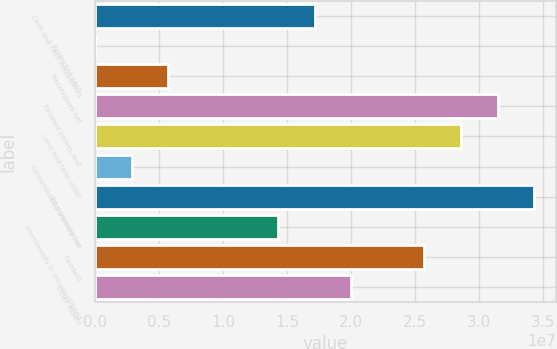Convert chart to OTSL. <chart><loc_0><loc_0><loc_500><loc_500><bar_chart><fcel>Cash and cash equivalents<fcel>Restricted cash<fcel>Receivables net<fcel>Finished homes and<fcel>Land and land under<fcel>Consolidated inventory not<fcel>Total inventories<fcel>Investments in unconsolidated<fcel>Goodwill<fcel>Other assets<nl><fcel>1.71447e+07<fcel>12399<fcel>5.72316e+06<fcel>3.14216e+07<fcel>2.85662e+07<fcel>2.86778e+06<fcel>3.42769e+07<fcel>1.42893e+07<fcel>2.57108e+07<fcel>2e+07<nl></chart> 